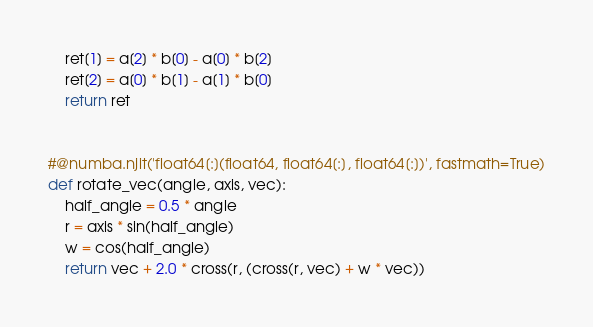<code> <loc_0><loc_0><loc_500><loc_500><_Python_>    ret[1] = a[2] * b[0] - a[0] * b[2]
    ret[2] = a[0] * b[1] - a[1] * b[0]
    return ret


#@numba.njit('float64[:](float64, float64[:], float64[:])', fastmath=True)
def rotate_vec(angle, axis, vec):
    half_angle = 0.5 * angle
    r = axis * sin(half_angle)
    w = cos(half_angle)
    return vec + 2.0 * cross(r, (cross(r, vec) + w * vec))
</code> 